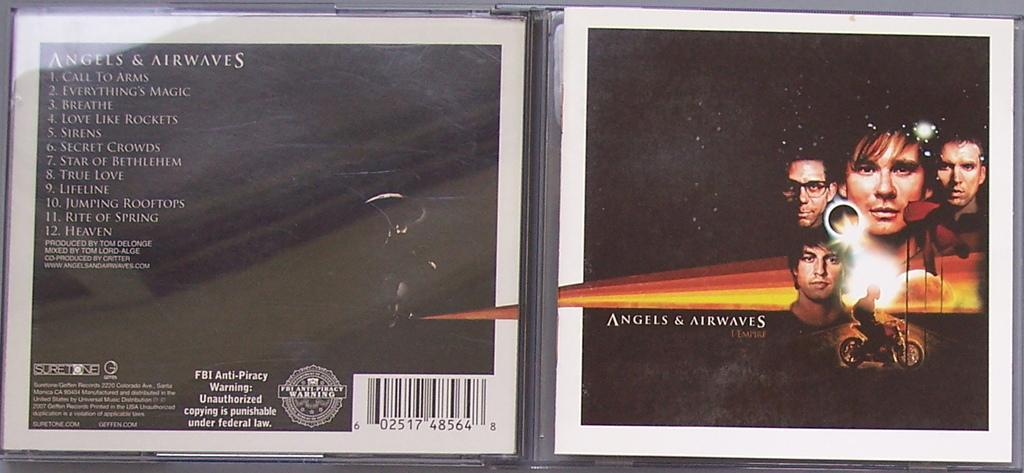Provide a one-sentence caption for the provided image. open cd case of angels & airwaves that has picture of 4 peoples heads and guy on a motorbike. 